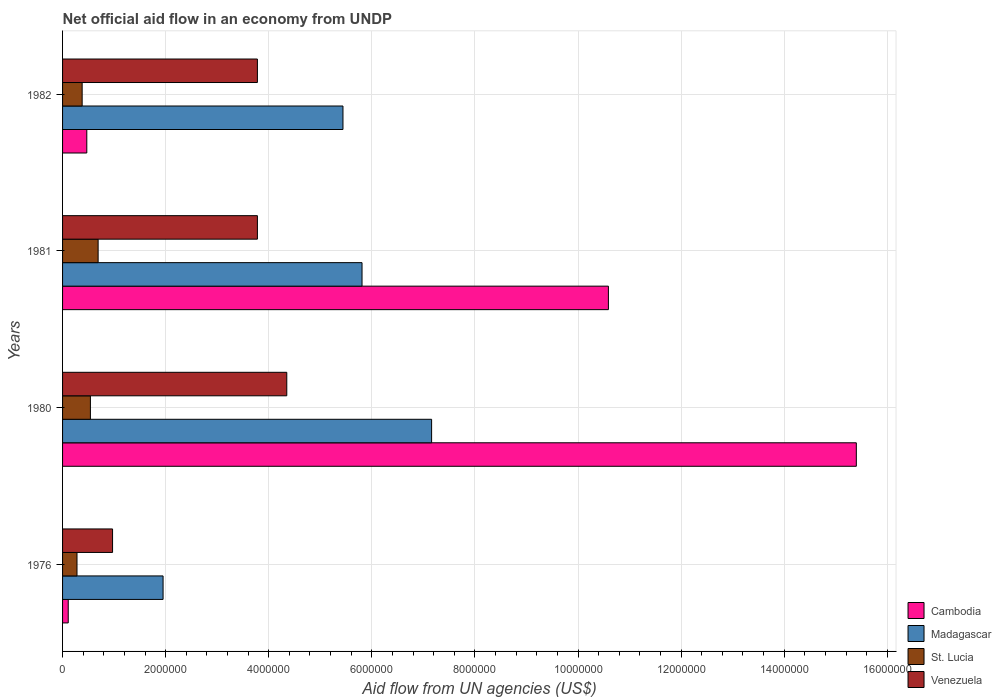How many groups of bars are there?
Provide a short and direct response. 4. How many bars are there on the 4th tick from the bottom?
Make the answer very short. 4. What is the label of the 4th group of bars from the top?
Keep it short and to the point. 1976. What is the net official aid flow in Venezuela in 1980?
Provide a short and direct response. 4.35e+06. Across all years, what is the maximum net official aid flow in Cambodia?
Provide a short and direct response. 1.54e+07. Across all years, what is the minimum net official aid flow in St. Lucia?
Your answer should be compact. 2.80e+05. In which year was the net official aid flow in Cambodia minimum?
Offer a very short reply. 1976. What is the total net official aid flow in Venezuela in the graph?
Make the answer very short. 1.29e+07. What is the difference between the net official aid flow in Cambodia in 1976 and that in 1981?
Your answer should be compact. -1.05e+07. What is the difference between the net official aid flow in Madagascar in 1980 and the net official aid flow in Cambodia in 1982?
Your answer should be compact. 6.69e+06. What is the average net official aid flow in Madagascar per year?
Your response must be concise. 5.09e+06. In the year 1976, what is the difference between the net official aid flow in St. Lucia and net official aid flow in Venezuela?
Provide a short and direct response. -6.90e+05. What is the ratio of the net official aid flow in St. Lucia in 1976 to that in 1980?
Offer a very short reply. 0.52. Is the net official aid flow in Cambodia in 1976 less than that in 1982?
Ensure brevity in your answer.  Yes. Is the difference between the net official aid flow in St. Lucia in 1976 and 1980 greater than the difference between the net official aid flow in Venezuela in 1976 and 1980?
Provide a succinct answer. Yes. What is the difference between the highest and the second highest net official aid flow in St. Lucia?
Make the answer very short. 1.50e+05. What is the difference between the highest and the lowest net official aid flow in Venezuela?
Keep it short and to the point. 3.38e+06. Is it the case that in every year, the sum of the net official aid flow in Madagascar and net official aid flow in St. Lucia is greater than the sum of net official aid flow in Cambodia and net official aid flow in Venezuela?
Keep it short and to the point. No. What does the 4th bar from the top in 1981 represents?
Your response must be concise. Cambodia. What does the 3rd bar from the bottom in 1980 represents?
Provide a succinct answer. St. Lucia. Is it the case that in every year, the sum of the net official aid flow in St. Lucia and net official aid flow in Venezuela is greater than the net official aid flow in Madagascar?
Make the answer very short. No. Are all the bars in the graph horizontal?
Your answer should be compact. Yes. How many years are there in the graph?
Provide a succinct answer. 4. What is the difference between two consecutive major ticks on the X-axis?
Your answer should be compact. 2.00e+06. Does the graph contain any zero values?
Ensure brevity in your answer.  No. Where does the legend appear in the graph?
Offer a terse response. Bottom right. How many legend labels are there?
Provide a short and direct response. 4. What is the title of the graph?
Provide a short and direct response. Net official aid flow in an economy from UNDP. What is the label or title of the X-axis?
Provide a short and direct response. Aid flow from UN agencies (US$). What is the label or title of the Y-axis?
Give a very brief answer. Years. What is the Aid flow from UN agencies (US$) in Cambodia in 1976?
Make the answer very short. 1.10e+05. What is the Aid flow from UN agencies (US$) of Madagascar in 1976?
Your response must be concise. 1.95e+06. What is the Aid flow from UN agencies (US$) of Venezuela in 1976?
Your response must be concise. 9.70e+05. What is the Aid flow from UN agencies (US$) in Cambodia in 1980?
Your answer should be compact. 1.54e+07. What is the Aid flow from UN agencies (US$) of Madagascar in 1980?
Keep it short and to the point. 7.16e+06. What is the Aid flow from UN agencies (US$) in St. Lucia in 1980?
Provide a short and direct response. 5.40e+05. What is the Aid flow from UN agencies (US$) in Venezuela in 1980?
Your answer should be compact. 4.35e+06. What is the Aid flow from UN agencies (US$) of Cambodia in 1981?
Your response must be concise. 1.06e+07. What is the Aid flow from UN agencies (US$) in Madagascar in 1981?
Offer a very short reply. 5.81e+06. What is the Aid flow from UN agencies (US$) in St. Lucia in 1981?
Give a very brief answer. 6.90e+05. What is the Aid flow from UN agencies (US$) of Venezuela in 1981?
Offer a very short reply. 3.78e+06. What is the Aid flow from UN agencies (US$) in Cambodia in 1982?
Your answer should be very brief. 4.70e+05. What is the Aid flow from UN agencies (US$) of Madagascar in 1982?
Provide a succinct answer. 5.44e+06. What is the Aid flow from UN agencies (US$) of St. Lucia in 1982?
Your answer should be very brief. 3.80e+05. What is the Aid flow from UN agencies (US$) in Venezuela in 1982?
Offer a terse response. 3.78e+06. Across all years, what is the maximum Aid flow from UN agencies (US$) in Cambodia?
Give a very brief answer. 1.54e+07. Across all years, what is the maximum Aid flow from UN agencies (US$) of Madagascar?
Make the answer very short. 7.16e+06. Across all years, what is the maximum Aid flow from UN agencies (US$) of St. Lucia?
Give a very brief answer. 6.90e+05. Across all years, what is the maximum Aid flow from UN agencies (US$) in Venezuela?
Your response must be concise. 4.35e+06. Across all years, what is the minimum Aid flow from UN agencies (US$) of Cambodia?
Give a very brief answer. 1.10e+05. Across all years, what is the minimum Aid flow from UN agencies (US$) of Madagascar?
Make the answer very short. 1.95e+06. Across all years, what is the minimum Aid flow from UN agencies (US$) of Venezuela?
Provide a short and direct response. 9.70e+05. What is the total Aid flow from UN agencies (US$) of Cambodia in the graph?
Make the answer very short. 2.66e+07. What is the total Aid flow from UN agencies (US$) in Madagascar in the graph?
Offer a terse response. 2.04e+07. What is the total Aid flow from UN agencies (US$) of St. Lucia in the graph?
Your response must be concise. 1.89e+06. What is the total Aid flow from UN agencies (US$) of Venezuela in the graph?
Offer a very short reply. 1.29e+07. What is the difference between the Aid flow from UN agencies (US$) of Cambodia in 1976 and that in 1980?
Make the answer very short. -1.53e+07. What is the difference between the Aid flow from UN agencies (US$) in Madagascar in 1976 and that in 1980?
Provide a succinct answer. -5.21e+06. What is the difference between the Aid flow from UN agencies (US$) of Venezuela in 1976 and that in 1980?
Make the answer very short. -3.38e+06. What is the difference between the Aid flow from UN agencies (US$) in Cambodia in 1976 and that in 1981?
Ensure brevity in your answer.  -1.05e+07. What is the difference between the Aid flow from UN agencies (US$) of Madagascar in 1976 and that in 1981?
Keep it short and to the point. -3.86e+06. What is the difference between the Aid flow from UN agencies (US$) of St. Lucia in 1976 and that in 1981?
Offer a very short reply. -4.10e+05. What is the difference between the Aid flow from UN agencies (US$) in Venezuela in 1976 and that in 1981?
Ensure brevity in your answer.  -2.81e+06. What is the difference between the Aid flow from UN agencies (US$) in Cambodia in 1976 and that in 1982?
Make the answer very short. -3.60e+05. What is the difference between the Aid flow from UN agencies (US$) of Madagascar in 1976 and that in 1982?
Provide a short and direct response. -3.49e+06. What is the difference between the Aid flow from UN agencies (US$) of St. Lucia in 1976 and that in 1982?
Your answer should be compact. -1.00e+05. What is the difference between the Aid flow from UN agencies (US$) of Venezuela in 1976 and that in 1982?
Provide a short and direct response. -2.81e+06. What is the difference between the Aid flow from UN agencies (US$) in Cambodia in 1980 and that in 1981?
Offer a terse response. 4.81e+06. What is the difference between the Aid flow from UN agencies (US$) in Madagascar in 1980 and that in 1981?
Ensure brevity in your answer.  1.35e+06. What is the difference between the Aid flow from UN agencies (US$) of Venezuela in 1980 and that in 1981?
Give a very brief answer. 5.70e+05. What is the difference between the Aid flow from UN agencies (US$) of Cambodia in 1980 and that in 1982?
Provide a short and direct response. 1.49e+07. What is the difference between the Aid flow from UN agencies (US$) of Madagascar in 1980 and that in 1982?
Give a very brief answer. 1.72e+06. What is the difference between the Aid flow from UN agencies (US$) of Venezuela in 1980 and that in 1982?
Your answer should be compact. 5.70e+05. What is the difference between the Aid flow from UN agencies (US$) in Cambodia in 1981 and that in 1982?
Offer a very short reply. 1.01e+07. What is the difference between the Aid flow from UN agencies (US$) of Madagascar in 1981 and that in 1982?
Offer a very short reply. 3.70e+05. What is the difference between the Aid flow from UN agencies (US$) of Venezuela in 1981 and that in 1982?
Your answer should be compact. 0. What is the difference between the Aid flow from UN agencies (US$) of Cambodia in 1976 and the Aid flow from UN agencies (US$) of Madagascar in 1980?
Give a very brief answer. -7.05e+06. What is the difference between the Aid flow from UN agencies (US$) of Cambodia in 1976 and the Aid flow from UN agencies (US$) of St. Lucia in 1980?
Provide a short and direct response. -4.30e+05. What is the difference between the Aid flow from UN agencies (US$) in Cambodia in 1976 and the Aid flow from UN agencies (US$) in Venezuela in 1980?
Your answer should be very brief. -4.24e+06. What is the difference between the Aid flow from UN agencies (US$) of Madagascar in 1976 and the Aid flow from UN agencies (US$) of St. Lucia in 1980?
Your answer should be compact. 1.41e+06. What is the difference between the Aid flow from UN agencies (US$) of Madagascar in 1976 and the Aid flow from UN agencies (US$) of Venezuela in 1980?
Make the answer very short. -2.40e+06. What is the difference between the Aid flow from UN agencies (US$) of St. Lucia in 1976 and the Aid flow from UN agencies (US$) of Venezuela in 1980?
Provide a short and direct response. -4.07e+06. What is the difference between the Aid flow from UN agencies (US$) in Cambodia in 1976 and the Aid flow from UN agencies (US$) in Madagascar in 1981?
Keep it short and to the point. -5.70e+06. What is the difference between the Aid flow from UN agencies (US$) of Cambodia in 1976 and the Aid flow from UN agencies (US$) of St. Lucia in 1981?
Provide a succinct answer. -5.80e+05. What is the difference between the Aid flow from UN agencies (US$) of Cambodia in 1976 and the Aid flow from UN agencies (US$) of Venezuela in 1981?
Ensure brevity in your answer.  -3.67e+06. What is the difference between the Aid flow from UN agencies (US$) in Madagascar in 1976 and the Aid flow from UN agencies (US$) in St. Lucia in 1981?
Your answer should be very brief. 1.26e+06. What is the difference between the Aid flow from UN agencies (US$) in Madagascar in 1976 and the Aid flow from UN agencies (US$) in Venezuela in 1981?
Provide a short and direct response. -1.83e+06. What is the difference between the Aid flow from UN agencies (US$) of St. Lucia in 1976 and the Aid flow from UN agencies (US$) of Venezuela in 1981?
Offer a terse response. -3.50e+06. What is the difference between the Aid flow from UN agencies (US$) of Cambodia in 1976 and the Aid flow from UN agencies (US$) of Madagascar in 1982?
Offer a very short reply. -5.33e+06. What is the difference between the Aid flow from UN agencies (US$) of Cambodia in 1976 and the Aid flow from UN agencies (US$) of Venezuela in 1982?
Give a very brief answer. -3.67e+06. What is the difference between the Aid flow from UN agencies (US$) of Madagascar in 1976 and the Aid flow from UN agencies (US$) of St. Lucia in 1982?
Your answer should be compact. 1.57e+06. What is the difference between the Aid flow from UN agencies (US$) in Madagascar in 1976 and the Aid flow from UN agencies (US$) in Venezuela in 1982?
Provide a short and direct response. -1.83e+06. What is the difference between the Aid flow from UN agencies (US$) in St. Lucia in 1976 and the Aid flow from UN agencies (US$) in Venezuela in 1982?
Offer a very short reply. -3.50e+06. What is the difference between the Aid flow from UN agencies (US$) in Cambodia in 1980 and the Aid flow from UN agencies (US$) in Madagascar in 1981?
Make the answer very short. 9.59e+06. What is the difference between the Aid flow from UN agencies (US$) of Cambodia in 1980 and the Aid flow from UN agencies (US$) of St. Lucia in 1981?
Ensure brevity in your answer.  1.47e+07. What is the difference between the Aid flow from UN agencies (US$) in Cambodia in 1980 and the Aid flow from UN agencies (US$) in Venezuela in 1981?
Ensure brevity in your answer.  1.16e+07. What is the difference between the Aid flow from UN agencies (US$) in Madagascar in 1980 and the Aid flow from UN agencies (US$) in St. Lucia in 1981?
Your response must be concise. 6.47e+06. What is the difference between the Aid flow from UN agencies (US$) of Madagascar in 1980 and the Aid flow from UN agencies (US$) of Venezuela in 1981?
Your response must be concise. 3.38e+06. What is the difference between the Aid flow from UN agencies (US$) of St. Lucia in 1980 and the Aid flow from UN agencies (US$) of Venezuela in 1981?
Give a very brief answer. -3.24e+06. What is the difference between the Aid flow from UN agencies (US$) of Cambodia in 1980 and the Aid flow from UN agencies (US$) of Madagascar in 1982?
Your answer should be very brief. 9.96e+06. What is the difference between the Aid flow from UN agencies (US$) of Cambodia in 1980 and the Aid flow from UN agencies (US$) of St. Lucia in 1982?
Keep it short and to the point. 1.50e+07. What is the difference between the Aid flow from UN agencies (US$) of Cambodia in 1980 and the Aid flow from UN agencies (US$) of Venezuela in 1982?
Give a very brief answer. 1.16e+07. What is the difference between the Aid flow from UN agencies (US$) of Madagascar in 1980 and the Aid flow from UN agencies (US$) of St. Lucia in 1982?
Provide a succinct answer. 6.78e+06. What is the difference between the Aid flow from UN agencies (US$) in Madagascar in 1980 and the Aid flow from UN agencies (US$) in Venezuela in 1982?
Offer a very short reply. 3.38e+06. What is the difference between the Aid flow from UN agencies (US$) of St. Lucia in 1980 and the Aid flow from UN agencies (US$) of Venezuela in 1982?
Your answer should be compact. -3.24e+06. What is the difference between the Aid flow from UN agencies (US$) of Cambodia in 1981 and the Aid flow from UN agencies (US$) of Madagascar in 1982?
Provide a succinct answer. 5.15e+06. What is the difference between the Aid flow from UN agencies (US$) of Cambodia in 1981 and the Aid flow from UN agencies (US$) of St. Lucia in 1982?
Make the answer very short. 1.02e+07. What is the difference between the Aid flow from UN agencies (US$) of Cambodia in 1981 and the Aid flow from UN agencies (US$) of Venezuela in 1982?
Provide a short and direct response. 6.81e+06. What is the difference between the Aid flow from UN agencies (US$) of Madagascar in 1981 and the Aid flow from UN agencies (US$) of St. Lucia in 1982?
Provide a short and direct response. 5.43e+06. What is the difference between the Aid flow from UN agencies (US$) in Madagascar in 1981 and the Aid flow from UN agencies (US$) in Venezuela in 1982?
Offer a terse response. 2.03e+06. What is the difference between the Aid flow from UN agencies (US$) in St. Lucia in 1981 and the Aid flow from UN agencies (US$) in Venezuela in 1982?
Ensure brevity in your answer.  -3.09e+06. What is the average Aid flow from UN agencies (US$) in Cambodia per year?
Ensure brevity in your answer.  6.64e+06. What is the average Aid flow from UN agencies (US$) of Madagascar per year?
Give a very brief answer. 5.09e+06. What is the average Aid flow from UN agencies (US$) in St. Lucia per year?
Keep it short and to the point. 4.72e+05. What is the average Aid flow from UN agencies (US$) in Venezuela per year?
Offer a very short reply. 3.22e+06. In the year 1976, what is the difference between the Aid flow from UN agencies (US$) in Cambodia and Aid flow from UN agencies (US$) in Madagascar?
Give a very brief answer. -1.84e+06. In the year 1976, what is the difference between the Aid flow from UN agencies (US$) in Cambodia and Aid flow from UN agencies (US$) in Venezuela?
Keep it short and to the point. -8.60e+05. In the year 1976, what is the difference between the Aid flow from UN agencies (US$) of Madagascar and Aid flow from UN agencies (US$) of St. Lucia?
Provide a succinct answer. 1.67e+06. In the year 1976, what is the difference between the Aid flow from UN agencies (US$) in Madagascar and Aid flow from UN agencies (US$) in Venezuela?
Offer a very short reply. 9.80e+05. In the year 1976, what is the difference between the Aid flow from UN agencies (US$) of St. Lucia and Aid flow from UN agencies (US$) of Venezuela?
Offer a very short reply. -6.90e+05. In the year 1980, what is the difference between the Aid flow from UN agencies (US$) of Cambodia and Aid flow from UN agencies (US$) of Madagascar?
Your answer should be compact. 8.24e+06. In the year 1980, what is the difference between the Aid flow from UN agencies (US$) of Cambodia and Aid flow from UN agencies (US$) of St. Lucia?
Give a very brief answer. 1.49e+07. In the year 1980, what is the difference between the Aid flow from UN agencies (US$) of Cambodia and Aid flow from UN agencies (US$) of Venezuela?
Keep it short and to the point. 1.10e+07. In the year 1980, what is the difference between the Aid flow from UN agencies (US$) of Madagascar and Aid flow from UN agencies (US$) of St. Lucia?
Your answer should be compact. 6.62e+06. In the year 1980, what is the difference between the Aid flow from UN agencies (US$) of Madagascar and Aid flow from UN agencies (US$) of Venezuela?
Your answer should be very brief. 2.81e+06. In the year 1980, what is the difference between the Aid flow from UN agencies (US$) of St. Lucia and Aid flow from UN agencies (US$) of Venezuela?
Keep it short and to the point. -3.81e+06. In the year 1981, what is the difference between the Aid flow from UN agencies (US$) of Cambodia and Aid flow from UN agencies (US$) of Madagascar?
Your answer should be compact. 4.78e+06. In the year 1981, what is the difference between the Aid flow from UN agencies (US$) of Cambodia and Aid flow from UN agencies (US$) of St. Lucia?
Make the answer very short. 9.90e+06. In the year 1981, what is the difference between the Aid flow from UN agencies (US$) of Cambodia and Aid flow from UN agencies (US$) of Venezuela?
Your answer should be very brief. 6.81e+06. In the year 1981, what is the difference between the Aid flow from UN agencies (US$) in Madagascar and Aid flow from UN agencies (US$) in St. Lucia?
Ensure brevity in your answer.  5.12e+06. In the year 1981, what is the difference between the Aid flow from UN agencies (US$) of Madagascar and Aid flow from UN agencies (US$) of Venezuela?
Offer a terse response. 2.03e+06. In the year 1981, what is the difference between the Aid flow from UN agencies (US$) in St. Lucia and Aid flow from UN agencies (US$) in Venezuela?
Provide a short and direct response. -3.09e+06. In the year 1982, what is the difference between the Aid flow from UN agencies (US$) in Cambodia and Aid flow from UN agencies (US$) in Madagascar?
Provide a short and direct response. -4.97e+06. In the year 1982, what is the difference between the Aid flow from UN agencies (US$) in Cambodia and Aid flow from UN agencies (US$) in St. Lucia?
Your answer should be very brief. 9.00e+04. In the year 1982, what is the difference between the Aid flow from UN agencies (US$) in Cambodia and Aid flow from UN agencies (US$) in Venezuela?
Offer a very short reply. -3.31e+06. In the year 1982, what is the difference between the Aid flow from UN agencies (US$) of Madagascar and Aid flow from UN agencies (US$) of St. Lucia?
Provide a succinct answer. 5.06e+06. In the year 1982, what is the difference between the Aid flow from UN agencies (US$) of Madagascar and Aid flow from UN agencies (US$) of Venezuela?
Offer a very short reply. 1.66e+06. In the year 1982, what is the difference between the Aid flow from UN agencies (US$) in St. Lucia and Aid flow from UN agencies (US$) in Venezuela?
Your response must be concise. -3.40e+06. What is the ratio of the Aid flow from UN agencies (US$) in Cambodia in 1976 to that in 1980?
Provide a short and direct response. 0.01. What is the ratio of the Aid flow from UN agencies (US$) in Madagascar in 1976 to that in 1980?
Make the answer very short. 0.27. What is the ratio of the Aid flow from UN agencies (US$) of St. Lucia in 1976 to that in 1980?
Provide a succinct answer. 0.52. What is the ratio of the Aid flow from UN agencies (US$) of Venezuela in 1976 to that in 1980?
Keep it short and to the point. 0.22. What is the ratio of the Aid flow from UN agencies (US$) in Cambodia in 1976 to that in 1981?
Offer a terse response. 0.01. What is the ratio of the Aid flow from UN agencies (US$) of Madagascar in 1976 to that in 1981?
Ensure brevity in your answer.  0.34. What is the ratio of the Aid flow from UN agencies (US$) in St. Lucia in 1976 to that in 1981?
Make the answer very short. 0.41. What is the ratio of the Aid flow from UN agencies (US$) in Venezuela in 1976 to that in 1981?
Ensure brevity in your answer.  0.26. What is the ratio of the Aid flow from UN agencies (US$) in Cambodia in 1976 to that in 1982?
Give a very brief answer. 0.23. What is the ratio of the Aid flow from UN agencies (US$) of Madagascar in 1976 to that in 1982?
Your answer should be very brief. 0.36. What is the ratio of the Aid flow from UN agencies (US$) in St. Lucia in 1976 to that in 1982?
Give a very brief answer. 0.74. What is the ratio of the Aid flow from UN agencies (US$) in Venezuela in 1976 to that in 1982?
Ensure brevity in your answer.  0.26. What is the ratio of the Aid flow from UN agencies (US$) in Cambodia in 1980 to that in 1981?
Offer a very short reply. 1.45. What is the ratio of the Aid flow from UN agencies (US$) of Madagascar in 1980 to that in 1981?
Keep it short and to the point. 1.23. What is the ratio of the Aid flow from UN agencies (US$) in St. Lucia in 1980 to that in 1981?
Offer a very short reply. 0.78. What is the ratio of the Aid flow from UN agencies (US$) in Venezuela in 1980 to that in 1981?
Provide a succinct answer. 1.15. What is the ratio of the Aid flow from UN agencies (US$) of Cambodia in 1980 to that in 1982?
Offer a very short reply. 32.77. What is the ratio of the Aid flow from UN agencies (US$) of Madagascar in 1980 to that in 1982?
Your answer should be compact. 1.32. What is the ratio of the Aid flow from UN agencies (US$) of St. Lucia in 1980 to that in 1982?
Keep it short and to the point. 1.42. What is the ratio of the Aid flow from UN agencies (US$) in Venezuela in 1980 to that in 1982?
Keep it short and to the point. 1.15. What is the ratio of the Aid flow from UN agencies (US$) of Cambodia in 1981 to that in 1982?
Your response must be concise. 22.53. What is the ratio of the Aid flow from UN agencies (US$) in Madagascar in 1981 to that in 1982?
Make the answer very short. 1.07. What is the ratio of the Aid flow from UN agencies (US$) in St. Lucia in 1981 to that in 1982?
Give a very brief answer. 1.82. What is the ratio of the Aid flow from UN agencies (US$) in Venezuela in 1981 to that in 1982?
Offer a very short reply. 1. What is the difference between the highest and the second highest Aid flow from UN agencies (US$) of Cambodia?
Ensure brevity in your answer.  4.81e+06. What is the difference between the highest and the second highest Aid flow from UN agencies (US$) in Madagascar?
Your answer should be compact. 1.35e+06. What is the difference between the highest and the second highest Aid flow from UN agencies (US$) in Venezuela?
Offer a terse response. 5.70e+05. What is the difference between the highest and the lowest Aid flow from UN agencies (US$) of Cambodia?
Ensure brevity in your answer.  1.53e+07. What is the difference between the highest and the lowest Aid flow from UN agencies (US$) in Madagascar?
Provide a succinct answer. 5.21e+06. What is the difference between the highest and the lowest Aid flow from UN agencies (US$) in Venezuela?
Offer a very short reply. 3.38e+06. 